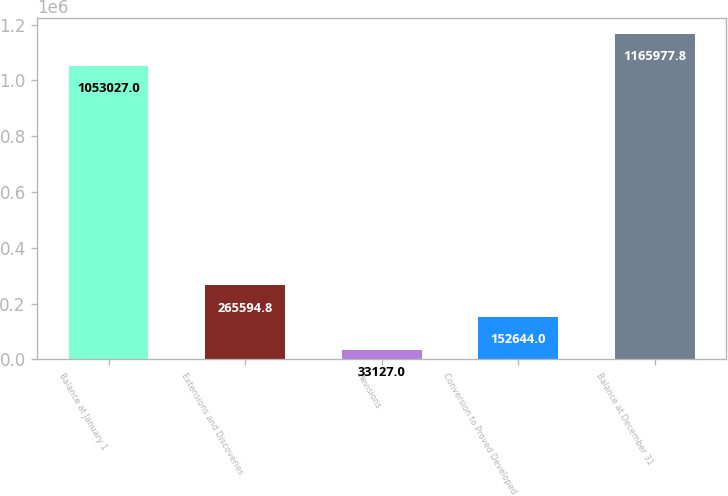Convert chart to OTSL. <chart><loc_0><loc_0><loc_500><loc_500><bar_chart><fcel>Balance at January 1<fcel>Extensions and Discoveries<fcel>Revisions<fcel>Conversion to Proved Developed<fcel>Balance at December 31<nl><fcel>1.05303e+06<fcel>265595<fcel>33127<fcel>152644<fcel>1.16598e+06<nl></chart> 